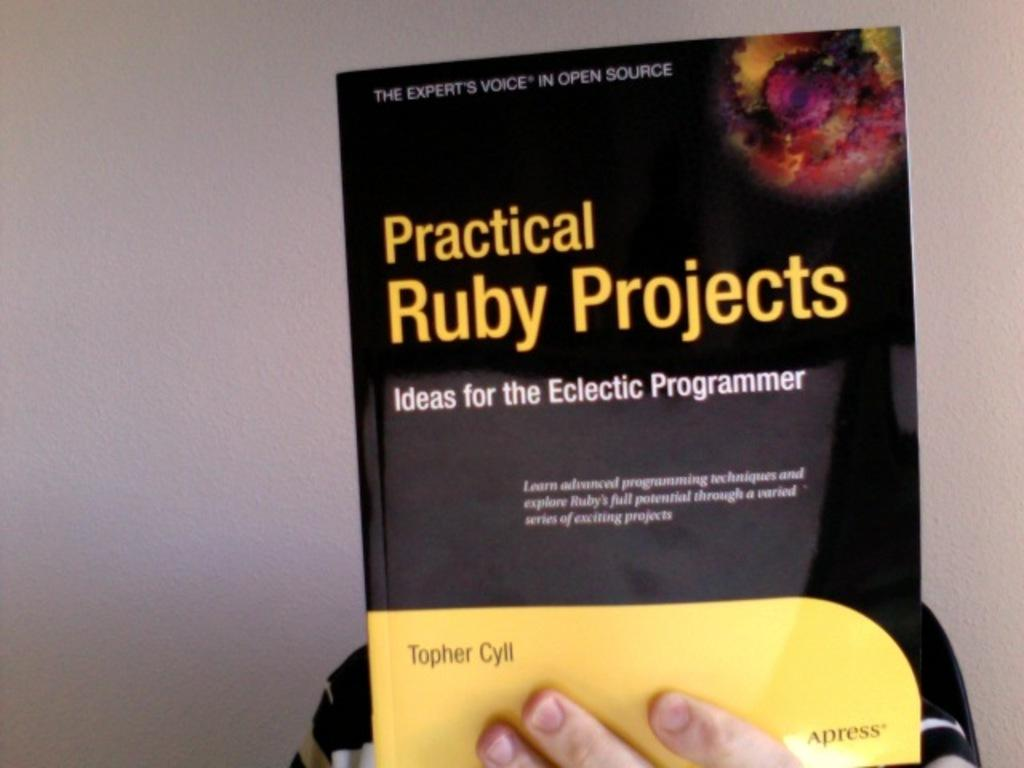What is the person in the background of the image holding? The person is holding a book in the background of the image. What can be seen on the book? The book has text written on it. What else is visible in the background of the image? There is a wall in the background of the image. What attempt is the person making to view the fact in the image? There is no attempt being made to view a fact in the image, as the person is simply holding a book with text on it. 